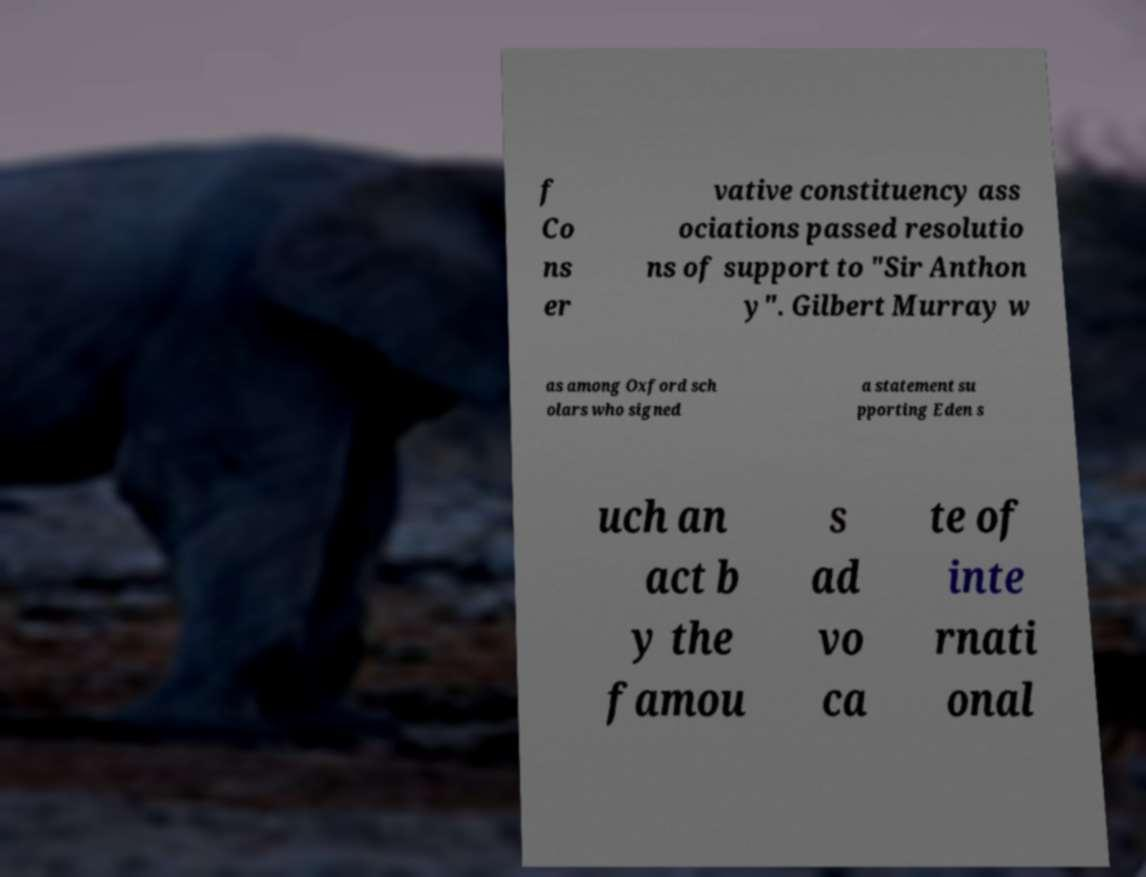What messages or text are displayed in this image? I need them in a readable, typed format. f Co ns er vative constituency ass ociations passed resolutio ns of support to "Sir Anthon y". Gilbert Murray w as among Oxford sch olars who signed a statement su pporting Eden s uch an act b y the famou s ad vo ca te of inte rnati onal 